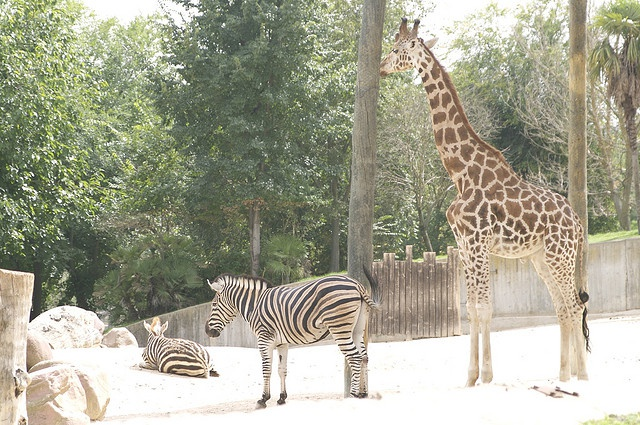Describe the objects in this image and their specific colors. I can see giraffe in darkgray, tan, gray, and ivory tones, zebra in darkgray, gray, ivory, and tan tones, and zebra in darkgray, ivory, gray, and tan tones in this image. 